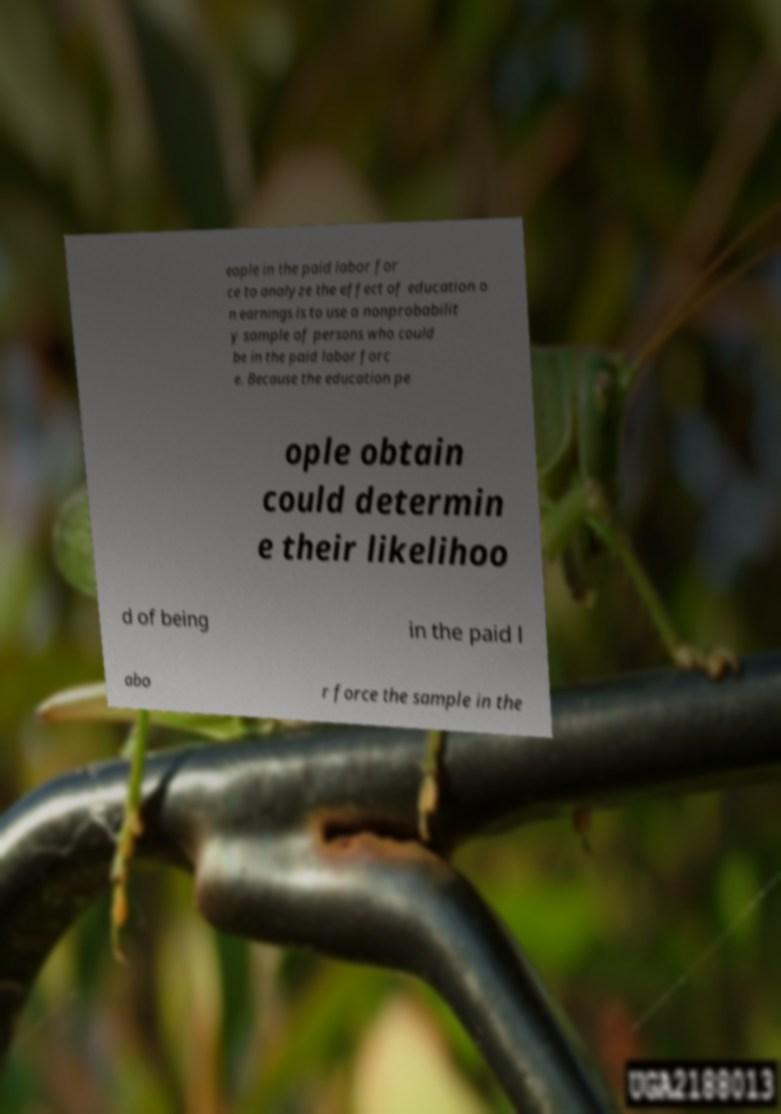What messages or text are displayed in this image? I need them in a readable, typed format. eople in the paid labor for ce to analyze the effect of education o n earnings is to use a nonprobabilit y sample of persons who could be in the paid labor forc e. Because the education pe ople obtain could determin e their likelihoo d of being in the paid l abo r force the sample in the 